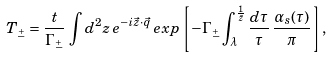Convert formula to latex. <formula><loc_0><loc_0><loc_500><loc_500>T _ { \stackrel { + } { - } } = \frac { t } { \Gamma _ { \stackrel { + } { - } } } \, \int d ^ { 2 } z \, e ^ { - i \vec { z } \cdot \vec { q } } \, e x p \left [ - \Gamma _ { \stackrel { + } { - } } \int _ { \lambda } ^ { \frac { 1 } { \bar { z } } } \frac { d \tau } { \tau } \, \frac { \alpha _ { s } ( \tau ) } { \pi } \right ] ,</formula> 